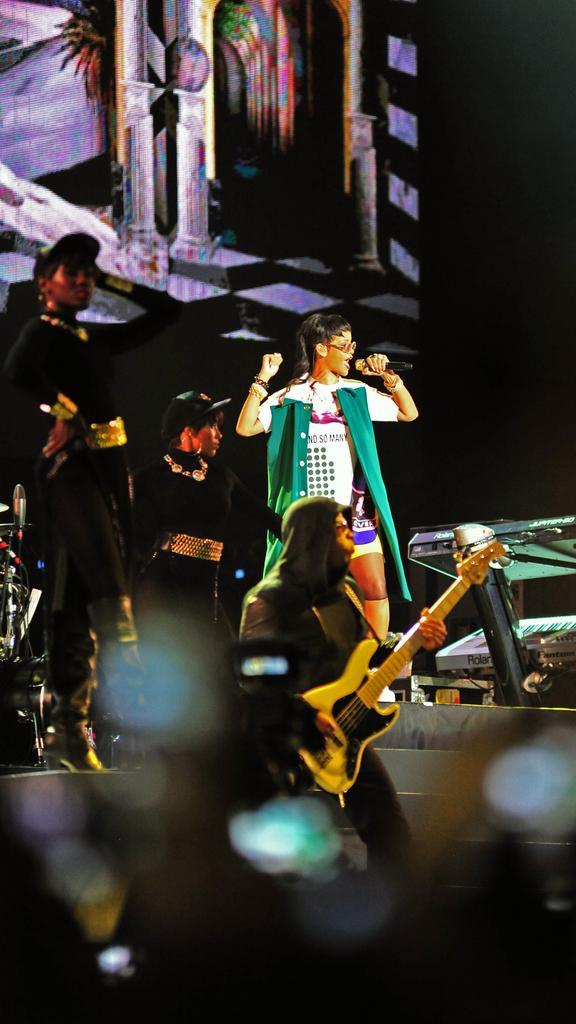Can you describe this image briefly? The image is taken in an event. In the center of the image we can see a person standing and holding a mic. On the right there is a lady performing. At the bottom we can see a person holding a guitar. In the background there is a board and a piano. 